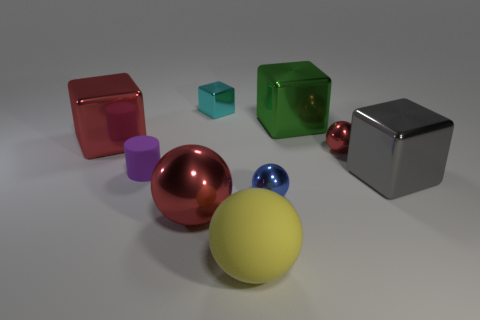There is a big metallic thing that is right of the cyan metal object and in front of the tiny matte object; what color is it?
Keep it short and to the point. Gray. Is there any other thing that has the same material as the cyan cube?
Offer a terse response. Yes. Is the big gray thing made of the same material as the red object in front of the gray metallic block?
Provide a succinct answer. Yes. What size is the matte thing that is behind the red ball in front of the large gray block?
Ensure brevity in your answer.  Small. Is there anything else of the same color as the large matte thing?
Offer a terse response. No. Are the red thing that is right of the large yellow matte thing and the big red object behind the tiny matte cylinder made of the same material?
Keep it short and to the point. Yes. There is a thing that is both behind the gray thing and in front of the tiny red shiny object; what material is it?
Offer a very short reply. Rubber. There is a tiny cyan object; is its shape the same as the red object that is to the left of the big red metallic ball?
Make the answer very short. Yes. What material is the red thing that is in front of the red metallic ball that is behind the red ball left of the matte sphere?
Your answer should be compact. Metal. What number of other objects are the same size as the yellow ball?
Make the answer very short. 4. 